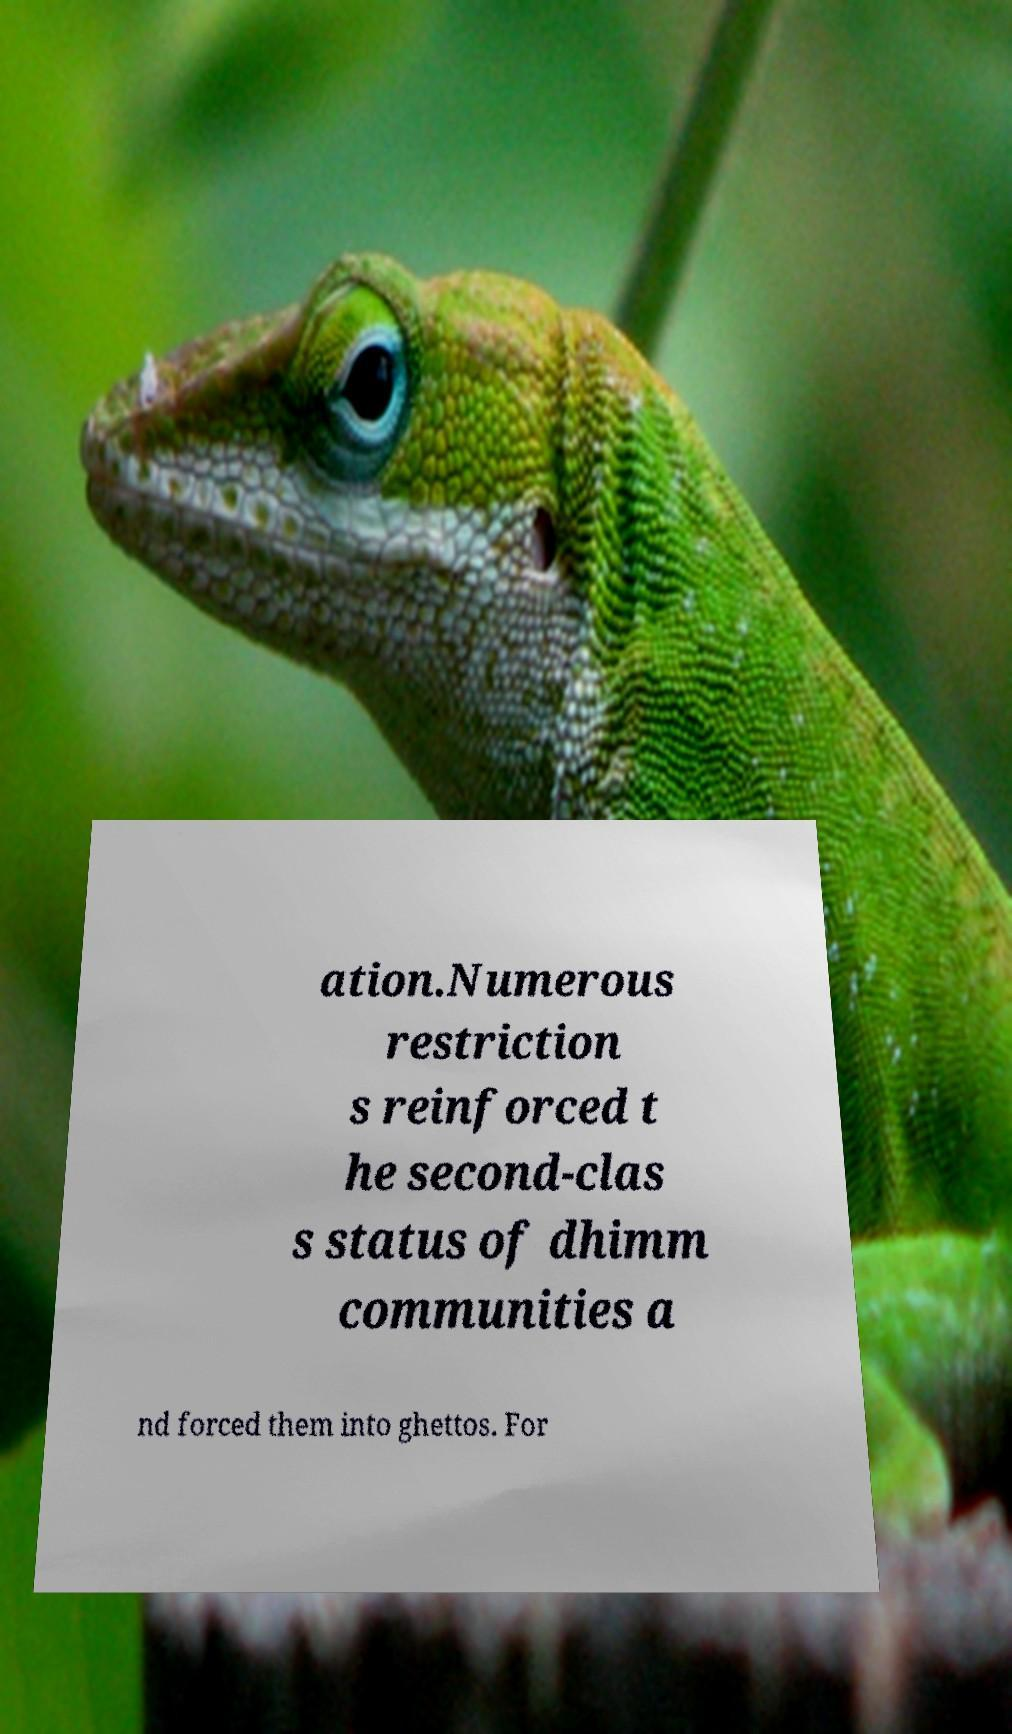There's text embedded in this image that I need extracted. Can you transcribe it verbatim? ation.Numerous restriction s reinforced t he second-clas s status of dhimm communities a nd forced them into ghettos. For 